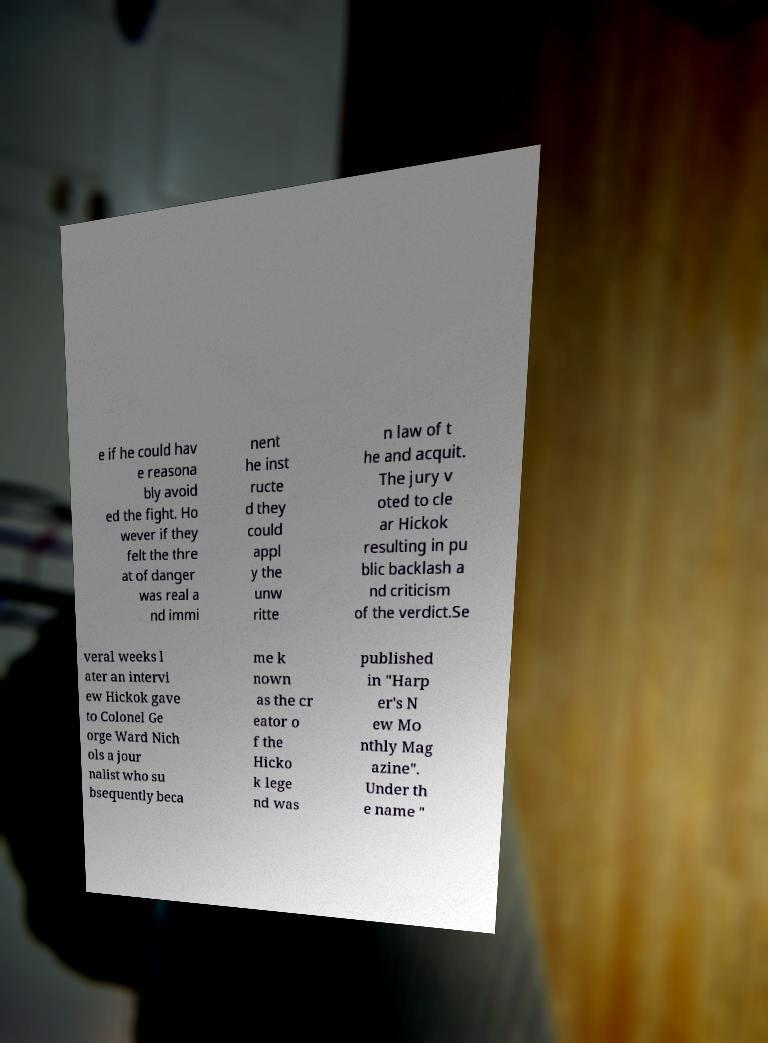Please read and relay the text visible in this image. What does it say? e if he could hav e reasona bly avoid ed the fight. Ho wever if they felt the thre at of danger was real a nd immi nent he inst ructe d they could appl y the unw ritte n law of t he and acquit. The jury v oted to cle ar Hickok resulting in pu blic backlash a nd criticism of the verdict.Se veral weeks l ater an intervi ew Hickok gave to Colonel Ge orge Ward Nich ols a jour nalist who su bsequently beca me k nown as the cr eator o f the Hicko k lege nd was published in "Harp er's N ew Mo nthly Mag azine". Under th e name " 